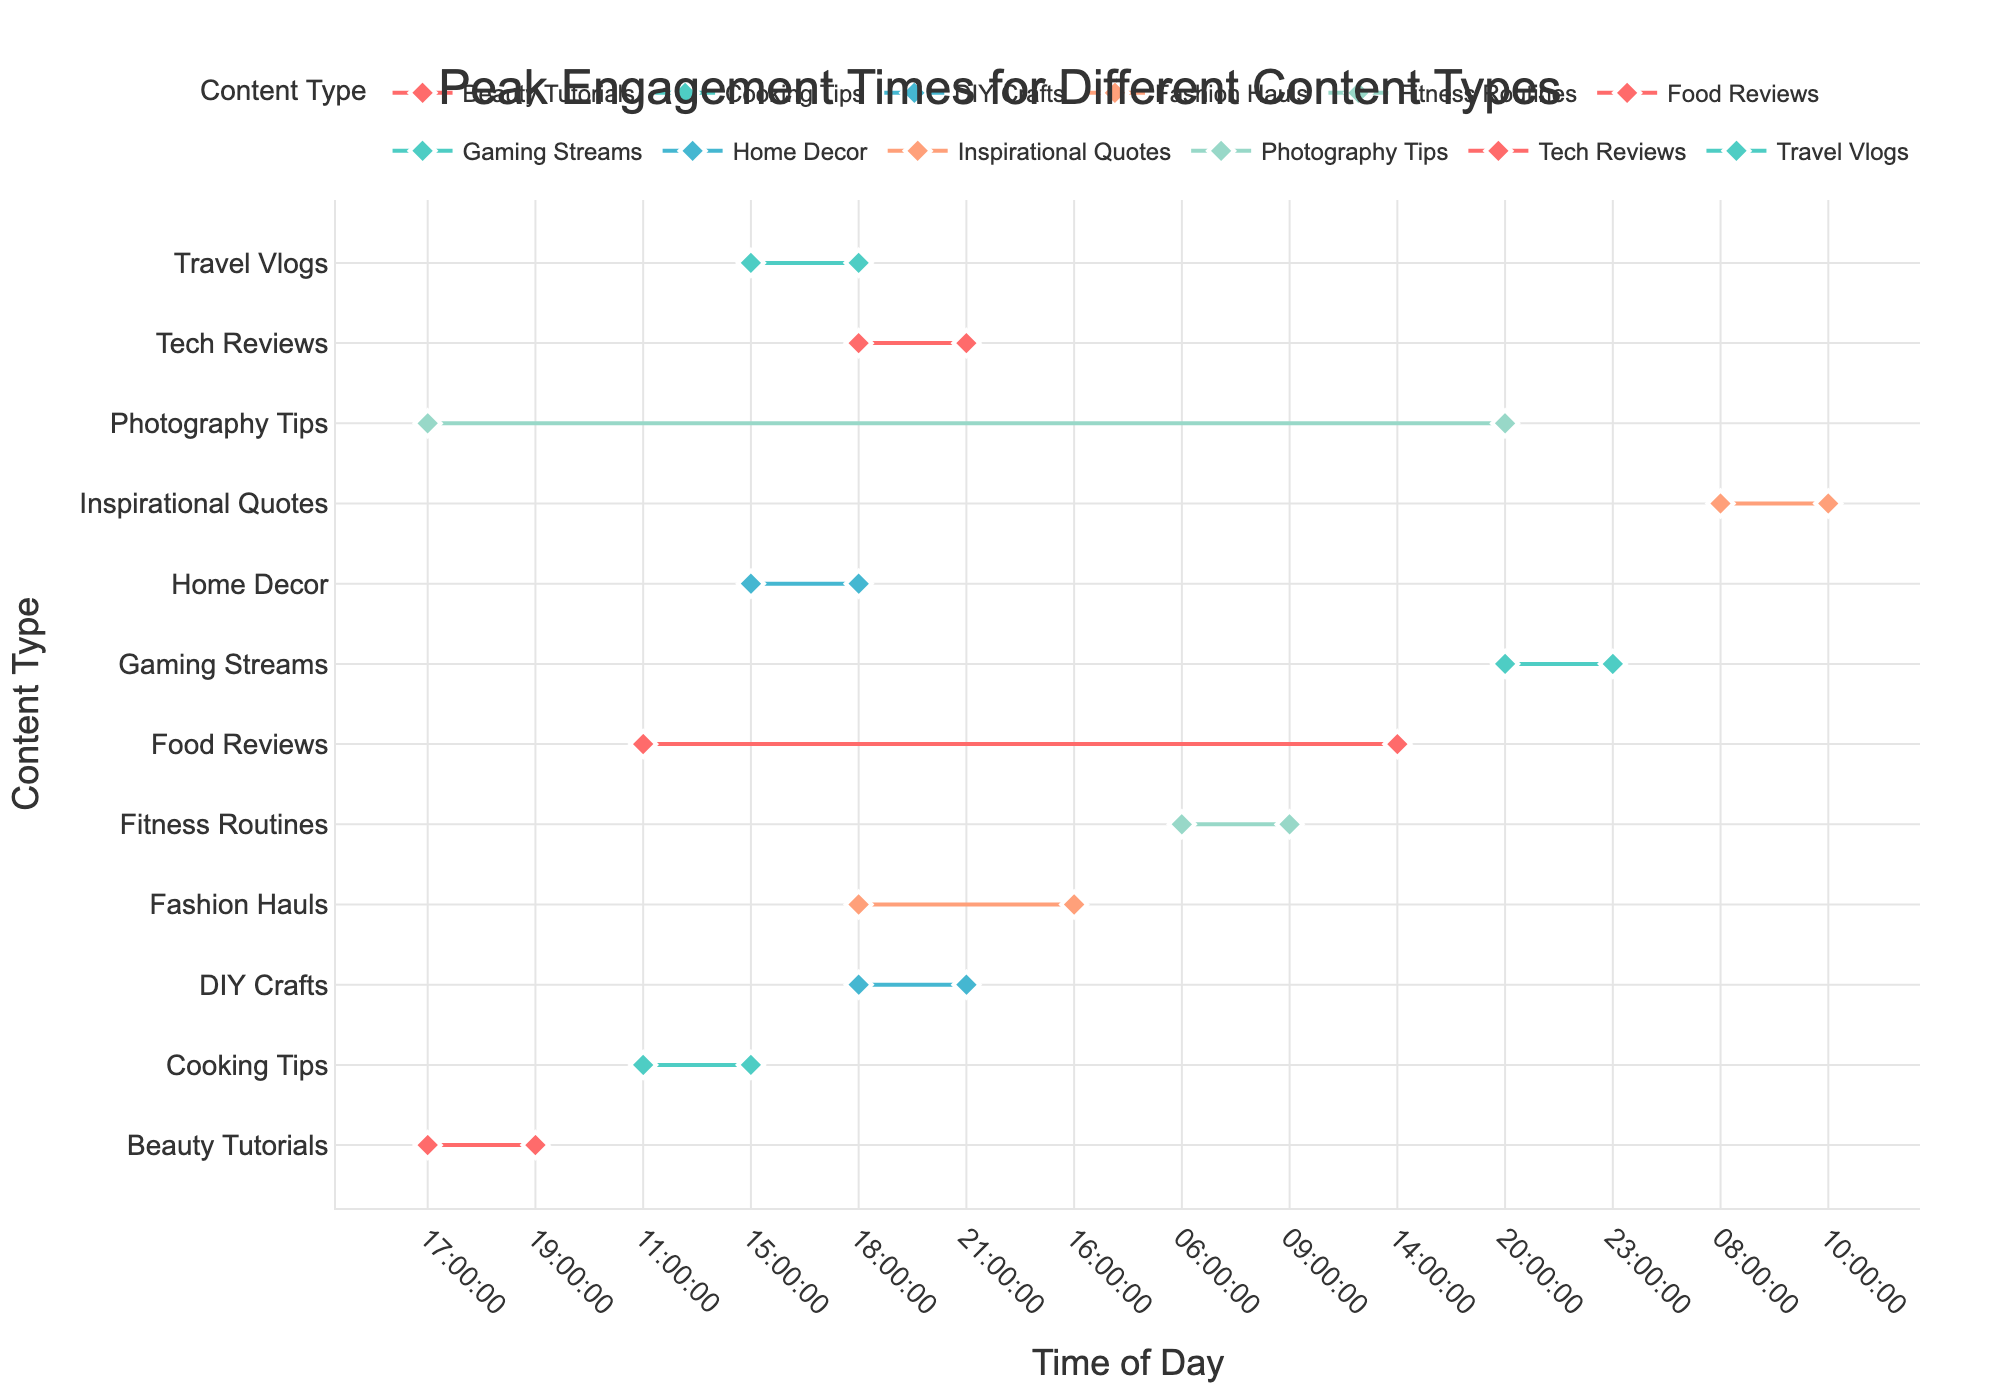What is the title of the plot? The title of the plot is usually located at the top of the figure in a larger font size for easy identification. The title provides a summary of what the plot is about.
Answer: Peak Engagement Times for Different Content Types What time range has the peak engagement for Travel Vlogs on YouTube? Look for the data point labeled "Travel Vlogs" on the plot. The range between the markers indicates the peak engagement time.
Answer: 15:00 to 18:00 Which content type has the earliest starting time for peak engagement? Examine the x-axis to see which content type has the earliest starting time. In this case, look for markers or lines starting at the earliest point on the time scale.
Answer: Fitness Routines (06:00) How does the peak engagement time for Tech Reviews compare to Gaming Streams? Identify and compare the range of times for Tech Reviews and Gaming Streams on the plot. Look at when each starts and ends.
Answer: Tech Reviews: 18:00 to 21:00, Gaming Streams: 20:00 to 23:00 Which content type on Pinterest has the longest duration for peak engagement? For Pinterest content types, check the duration by inspecting the time range for each and identifying the longest one.
Answer: DIY Crafts (18:00 to 21:00) What is the average starting time for peak engagement across all YouTube content types? First list all the starting times for YouTube content types, convert to a numerical format (hours), sum them up, and divide by the number of content types to get the average.
Answer: (15+11+18+17+20+16)/6 = 16:00 Which Instagram content has peak engagement later in the day compared to Cooking Tips? Identify the time ranges for Cooking Tips and other Instagram content types. Compare start and end times to determine which starts later.
Answer: Photography Tips (17:00 to 20:00) What is the difference in peak engagement end times between Home Decor and Fashion Hauls? Locate the end times for both Home Decor and Fashion Hauls. Subtract the end time of Fashion Hauls from Home Decor.
Answer: Both end at 18:00, so the difference is 0 hours 